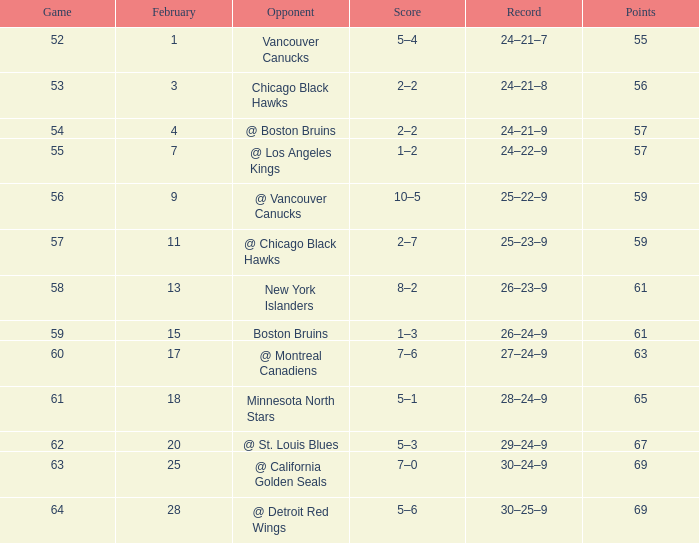How many games have more than 69 points and a 30-25-9 record? 0.0. 